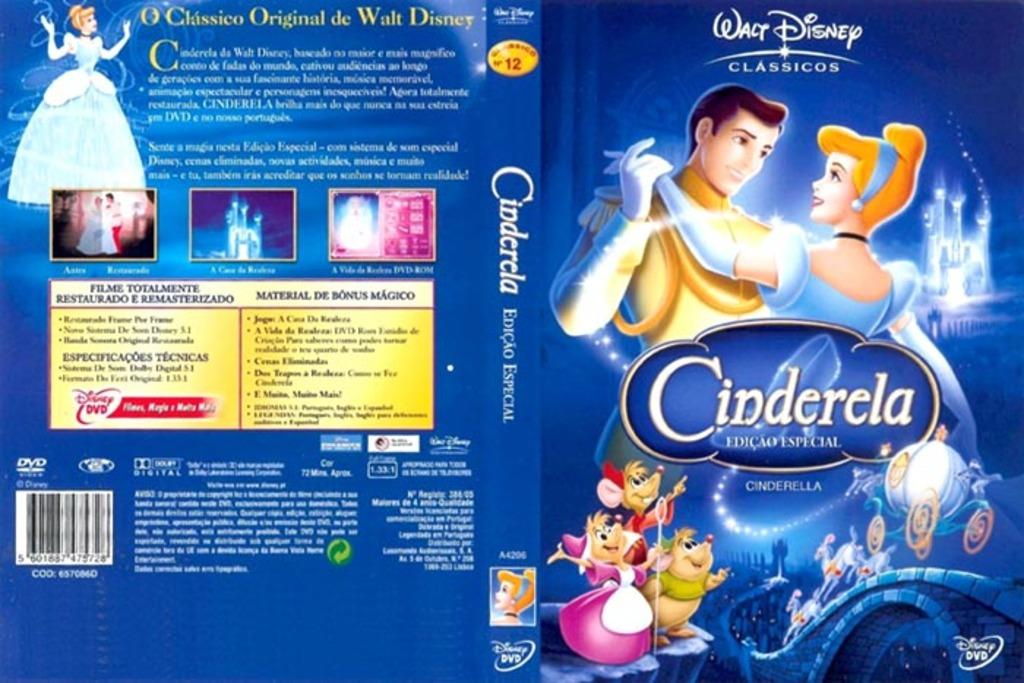What type of visual is the image? The image is a poster. What kind of content is featured on the poster? There are cartoons on the poster. What color is the shirt worn by the cartoon character in the image? There is no shirt worn by a cartoon character in the image, as the facts only mention that there are cartoons on the poster. 